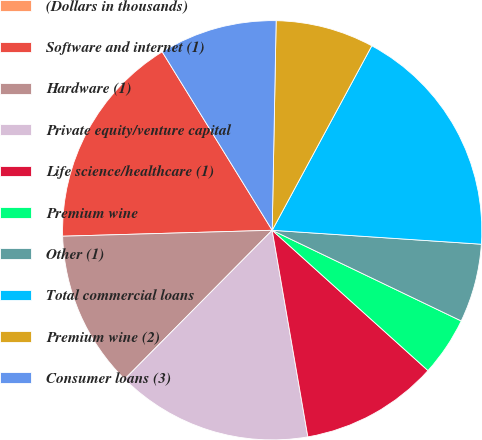Convert chart. <chart><loc_0><loc_0><loc_500><loc_500><pie_chart><fcel>(Dollars in thousands)<fcel>Software and internet (1)<fcel>Hardware (1)<fcel>Private equity/venture capital<fcel>Life science/healthcare (1)<fcel>Premium wine<fcel>Other (1)<fcel>Total commercial loans<fcel>Premium wine (2)<fcel>Consumer loans (3)<nl><fcel>0.0%<fcel>16.66%<fcel>12.12%<fcel>15.15%<fcel>10.61%<fcel>4.55%<fcel>6.06%<fcel>18.18%<fcel>7.58%<fcel>9.09%<nl></chart> 